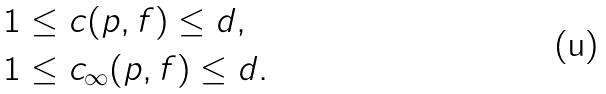Convert formula to latex. <formula><loc_0><loc_0><loc_500><loc_500>1 & \leq c ( p , f ) \leq d , \\ 1 & \leq c _ { \infty } ( p , f ) \leq d .</formula> 